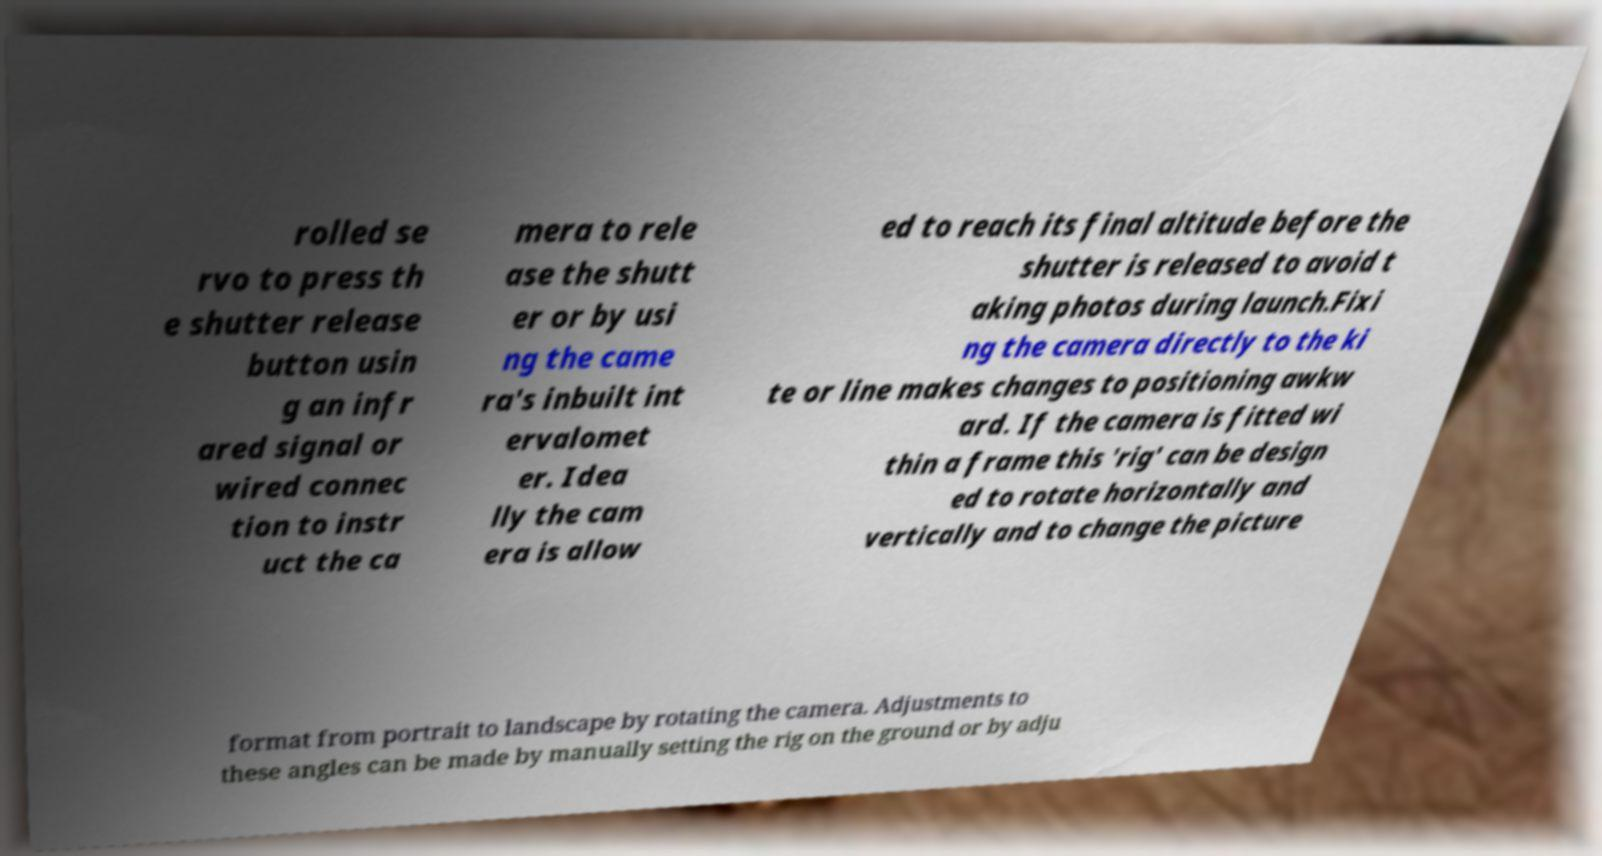Can you read and provide the text displayed in the image?This photo seems to have some interesting text. Can you extract and type it out for me? rolled se rvo to press th e shutter release button usin g an infr ared signal or wired connec tion to instr uct the ca mera to rele ase the shutt er or by usi ng the came ra's inbuilt int ervalomet er. Idea lly the cam era is allow ed to reach its final altitude before the shutter is released to avoid t aking photos during launch.Fixi ng the camera directly to the ki te or line makes changes to positioning awkw ard. If the camera is fitted wi thin a frame this 'rig' can be design ed to rotate horizontally and vertically and to change the picture format from portrait to landscape by rotating the camera. Adjustments to these angles can be made by manually setting the rig on the ground or by adju 